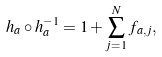Convert formula to latex. <formula><loc_0><loc_0><loc_500><loc_500>h _ { a } \circ h _ { a } ^ { - 1 } = 1 + \sum _ { j = 1 } ^ { N } f _ { a , j } ,</formula> 